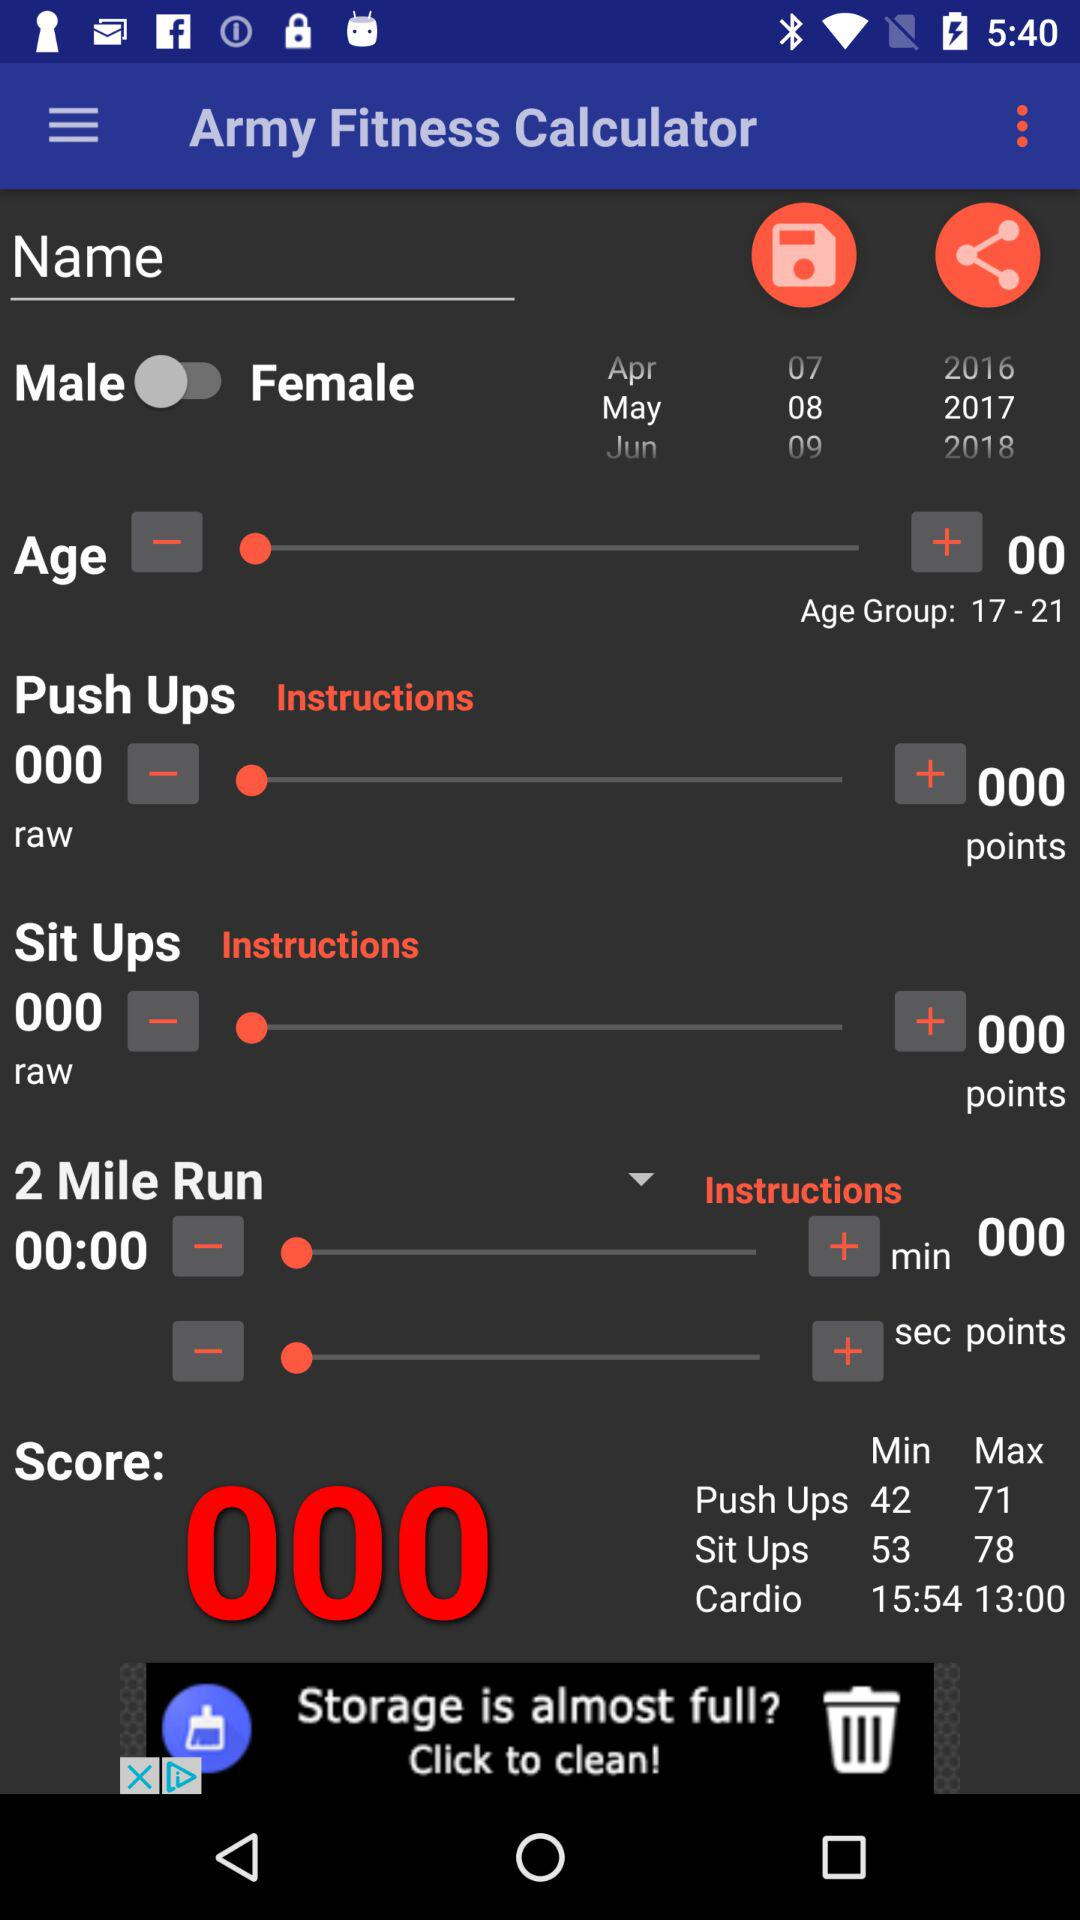What is the age group of the user?
Answer the question using a single word or phrase. 17-21 